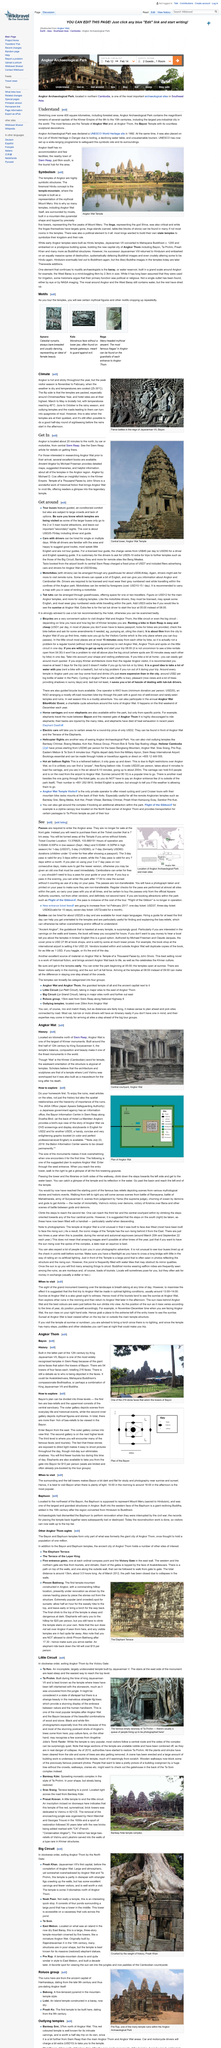Highlight a few significant elements in this photo. The peak visitor season in Angkor typically occurs from November to February, during which time the weather is dry and the temperature is cool, typically ranging between 25 to 30 degrees Celsius, making it an ideal time to visit the temples for many tourists. The above picture was taken at the famous doorway of Ta Prohm. The photograph depicts a monument called Angkor Wat. The construction of Ta Keo was commissioned by Jayavarman V. Tickets for Angkor Wat are not available for purchase at the gate. 